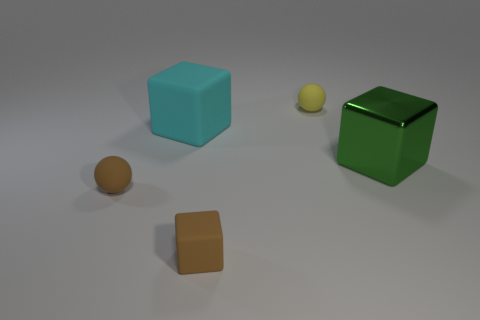What shape is the tiny rubber object behind the green thing?
Make the answer very short. Sphere. What size is the sphere that is the same color as the tiny matte cube?
Ensure brevity in your answer.  Small. Is there a gray rubber block of the same size as the cyan rubber block?
Provide a succinct answer. No. Is the material of the tiny object that is behind the green metal object the same as the brown block?
Keep it short and to the point. Yes. Are there an equal number of small balls left of the yellow thing and green objects that are on the right side of the green shiny object?
Your answer should be compact. No. There is a tiny matte object that is to the right of the cyan matte block and in front of the tiny yellow rubber ball; what is its shape?
Offer a very short reply. Cube. There is a cyan matte cube; how many tiny brown matte balls are on the right side of it?
Make the answer very short. 0. What number of other things are the same shape as the large green metal thing?
Keep it short and to the point. 2. Is the number of large gray cylinders less than the number of tiny brown balls?
Ensure brevity in your answer.  Yes. How big is the rubber thing that is both in front of the green shiny block and to the right of the brown sphere?
Your answer should be compact. Small. 